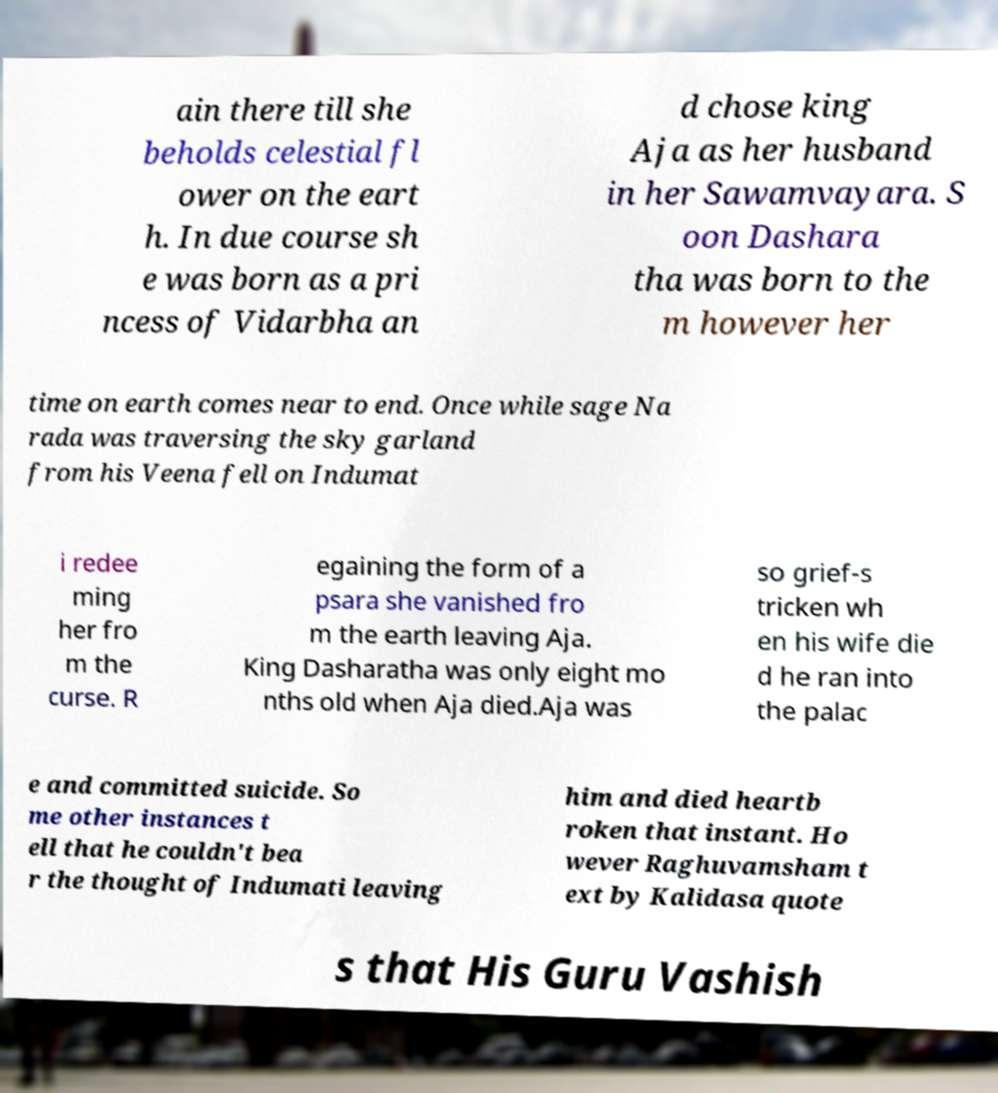Could you extract and type out the text from this image? ain there till she beholds celestial fl ower on the eart h. In due course sh e was born as a pri ncess of Vidarbha an d chose king Aja as her husband in her Sawamvayara. S oon Dashara tha was born to the m however her time on earth comes near to end. Once while sage Na rada was traversing the sky garland from his Veena fell on Indumat i redee ming her fro m the curse. R egaining the form of a psara she vanished fro m the earth leaving Aja. King Dasharatha was only eight mo nths old when Aja died.Aja was so grief-s tricken wh en his wife die d he ran into the palac e and committed suicide. So me other instances t ell that he couldn't bea r the thought of Indumati leaving him and died heartb roken that instant. Ho wever Raghuvamsham t ext by Kalidasa quote s that His Guru Vashish 